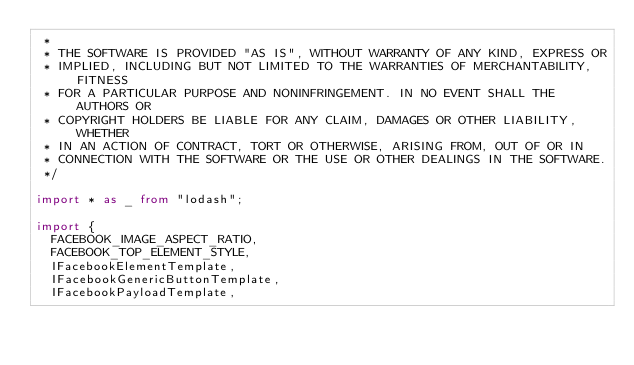<code> <loc_0><loc_0><loc_500><loc_500><_TypeScript_> *
 * THE SOFTWARE IS PROVIDED "AS IS", WITHOUT WARRANTY OF ANY KIND, EXPRESS OR
 * IMPLIED, INCLUDING BUT NOT LIMITED TO THE WARRANTIES OF MERCHANTABILITY, FITNESS
 * FOR A PARTICULAR PURPOSE AND NONINFRINGEMENT. IN NO EVENT SHALL THE AUTHORS OR
 * COPYRIGHT HOLDERS BE LIABLE FOR ANY CLAIM, DAMAGES OR OTHER LIABILITY, WHETHER
 * IN AN ACTION OF CONTRACT, TORT OR OTHERWISE, ARISING FROM, OUT OF OR IN
 * CONNECTION WITH THE SOFTWARE OR THE USE OR OTHER DEALINGS IN THE SOFTWARE.
 */

import * as _ from "lodash";

import {
  FACEBOOK_IMAGE_ASPECT_RATIO,
  FACEBOOK_TOP_ELEMENT_STYLE,
  IFacebookElementTemplate,
  IFacebookGenericButtonTemplate,
  IFacebookPayloadTemplate,</code> 